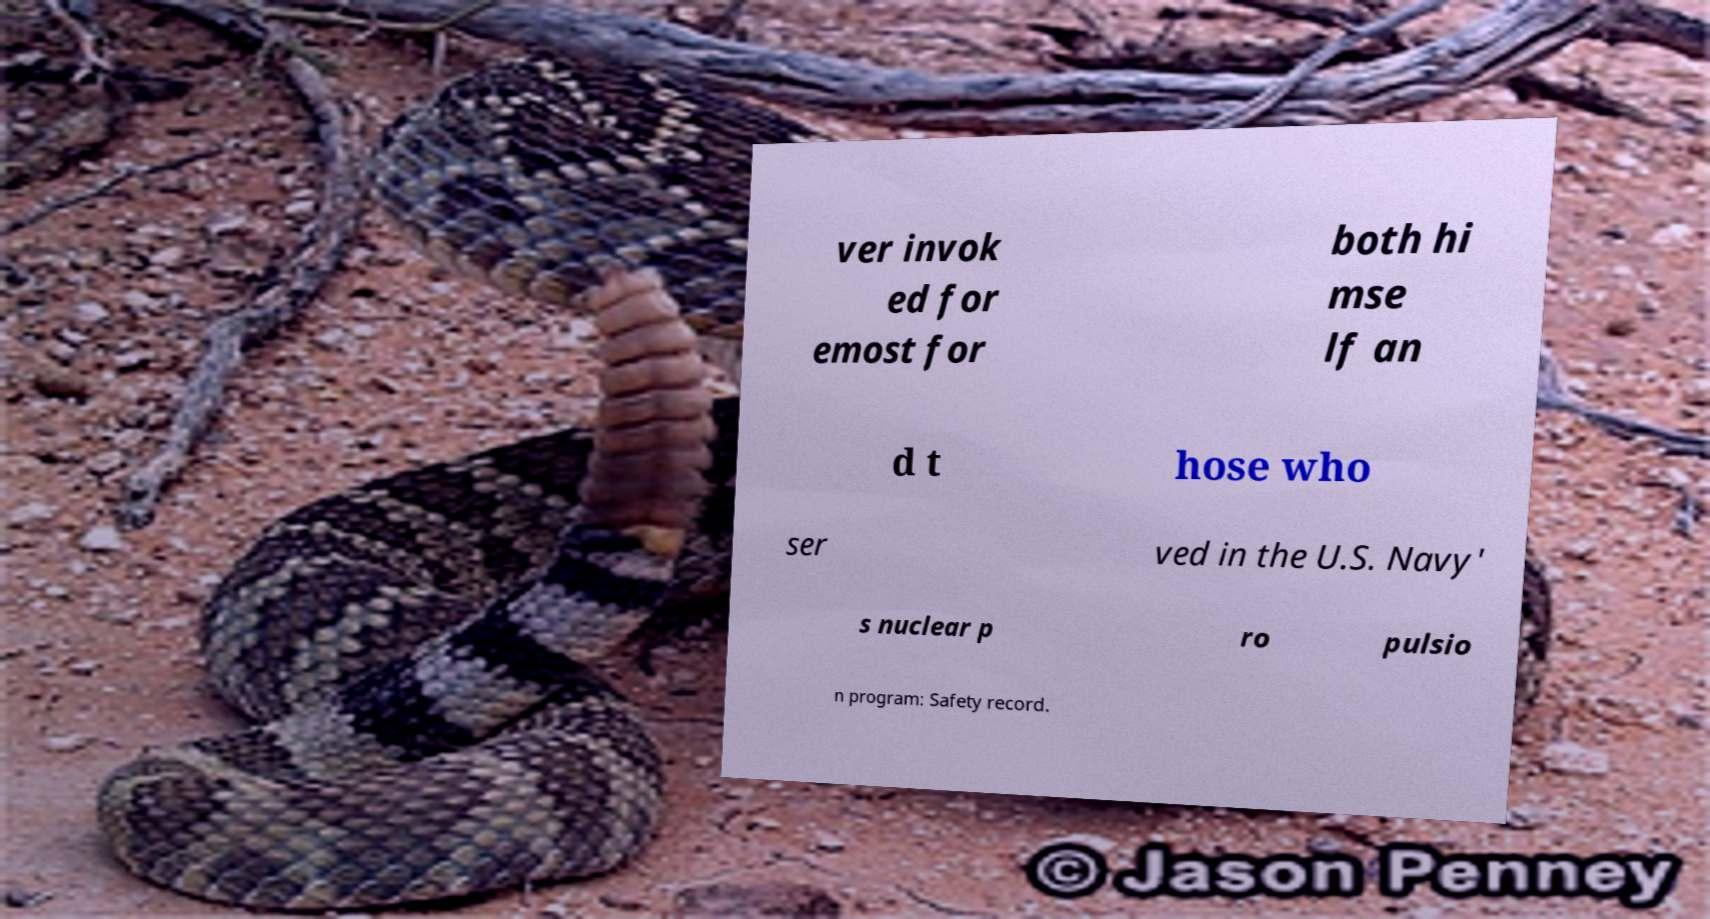For documentation purposes, I need the text within this image transcribed. Could you provide that? ver invok ed for emost for both hi mse lf an d t hose who ser ved in the U.S. Navy' s nuclear p ro pulsio n program: Safety record. 